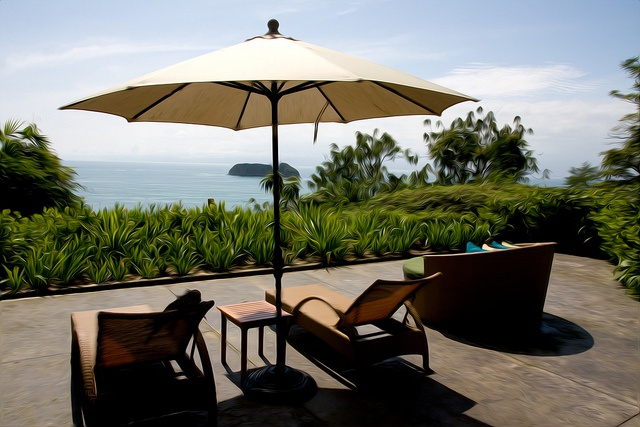Describe the objects in this image and their specific colors. I can see umbrella in darkgray, ivory, olive, and black tones, chair in darkgray, black, tan, and maroon tones, chair in darkgray, black, tan, olive, and maroon tones, chair in darkgray, black, tan, and maroon tones, and dining table in darkgray, black, tan, and gray tones in this image. 